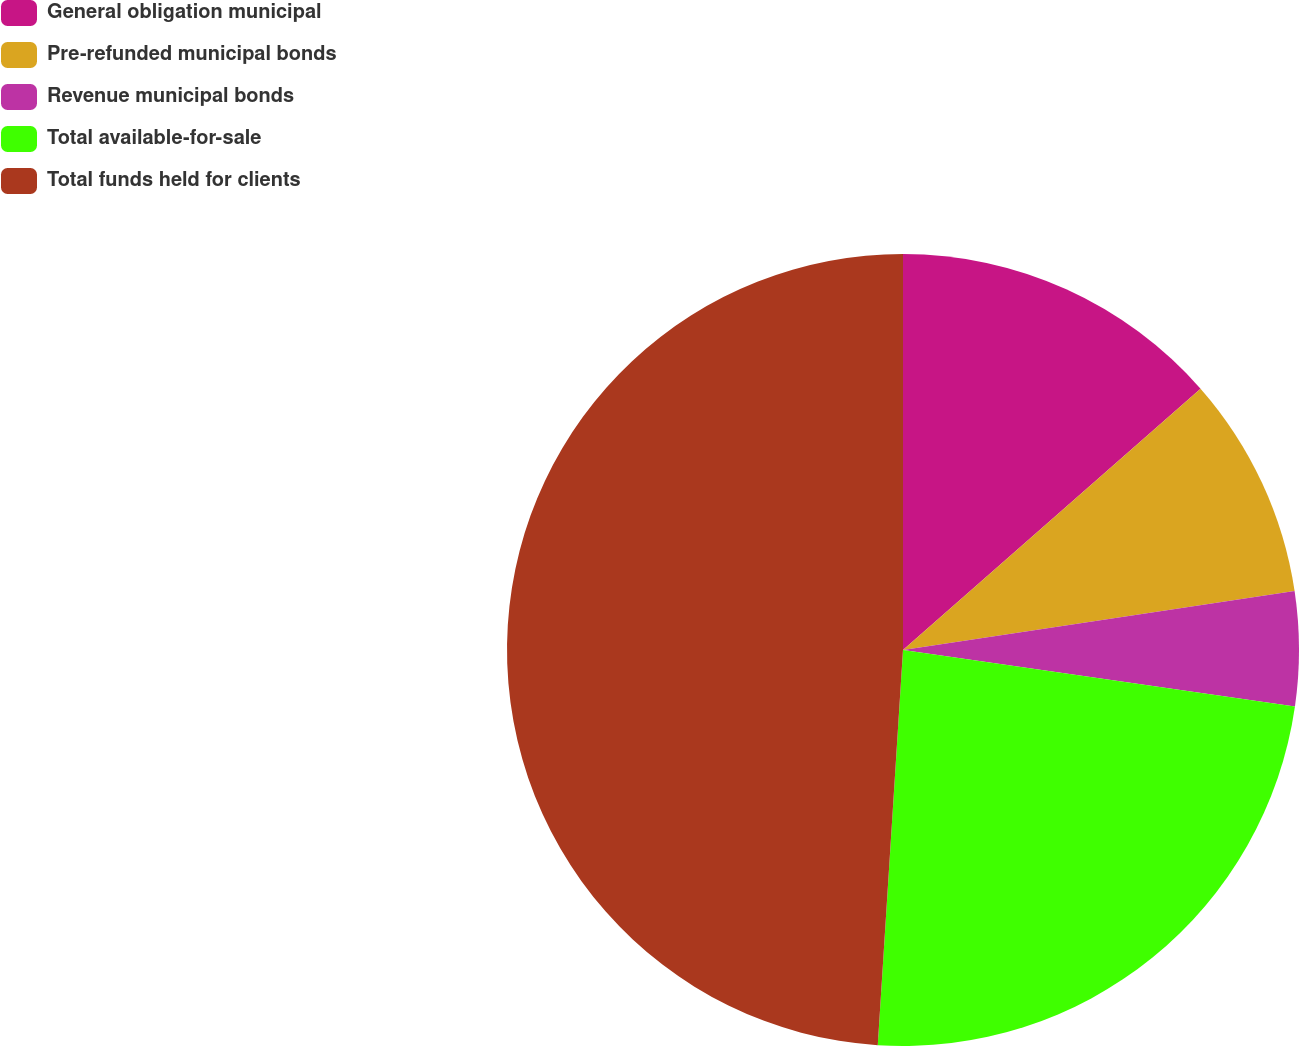Convert chart to OTSL. <chart><loc_0><loc_0><loc_500><loc_500><pie_chart><fcel>General obligation municipal<fcel>Pre-refunded municipal bonds<fcel>Revenue municipal bonds<fcel>Total available-for-sale<fcel>Total funds held for clients<nl><fcel>13.53%<fcel>9.09%<fcel>4.66%<fcel>23.73%<fcel>48.98%<nl></chart> 